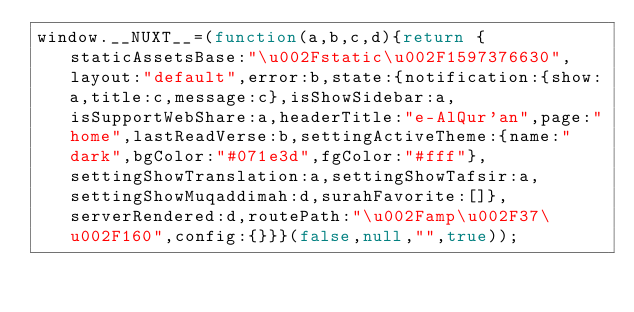Convert code to text. <code><loc_0><loc_0><loc_500><loc_500><_JavaScript_>window.__NUXT__=(function(a,b,c,d){return {staticAssetsBase:"\u002Fstatic\u002F1597376630",layout:"default",error:b,state:{notification:{show:a,title:c,message:c},isShowSidebar:a,isSupportWebShare:a,headerTitle:"e-AlQur'an",page:"home",lastReadVerse:b,settingActiveTheme:{name:"dark",bgColor:"#071e3d",fgColor:"#fff"},settingShowTranslation:a,settingShowTafsir:a,settingShowMuqaddimah:d,surahFavorite:[]},serverRendered:d,routePath:"\u002Famp\u002F37\u002F160",config:{}}}(false,null,"",true));</code> 